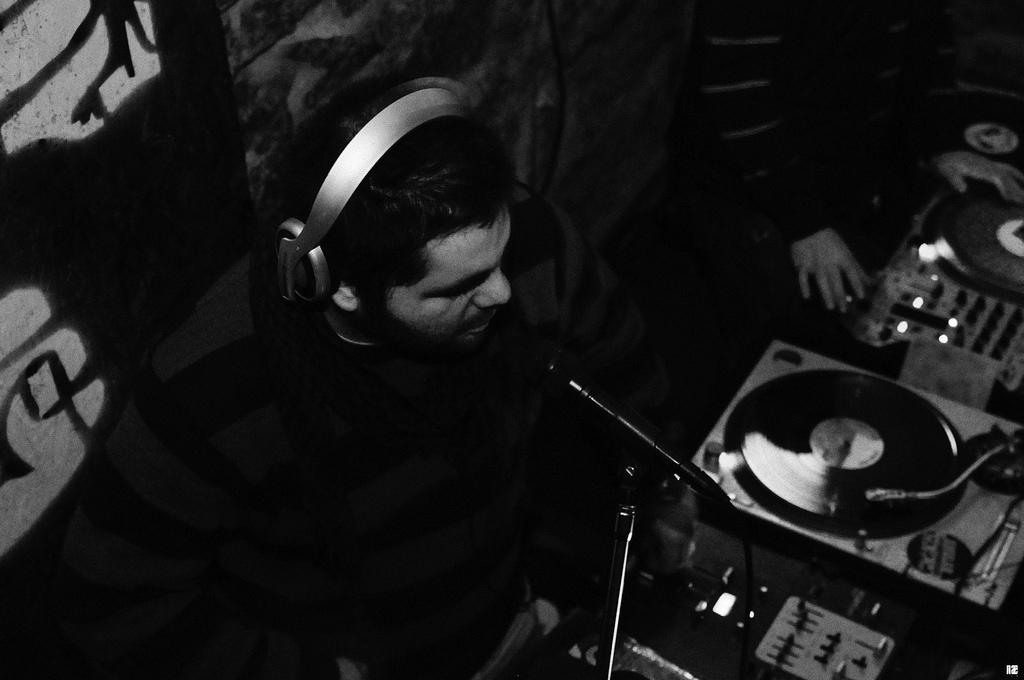What is the color scheme of the image? The image is black and white. What is the person in the image doing? The person has a headset and a microphone, suggesting they might be involved in broadcasting or communication. What type of objects can be seen in the image? Electronic devices are present in the image. What is on the wall in the image? There are paintings on a board on the wall. Can you describe any body parts visible in the image? A hand of a person is visible in the image. Can you tell me how many rivers are visible in the image? There are no rivers visible in the image; it is a black and white image with a person wearing a headset and a microphone, electronic devices, paintings on a board on the wall, and a visible hand. What type of wing is attached to the person in the image? There is no wing attached to the person in the image; they are wearing a headset and a microphone and are surrounded by electronic devices and paintings on a board on the wall. 